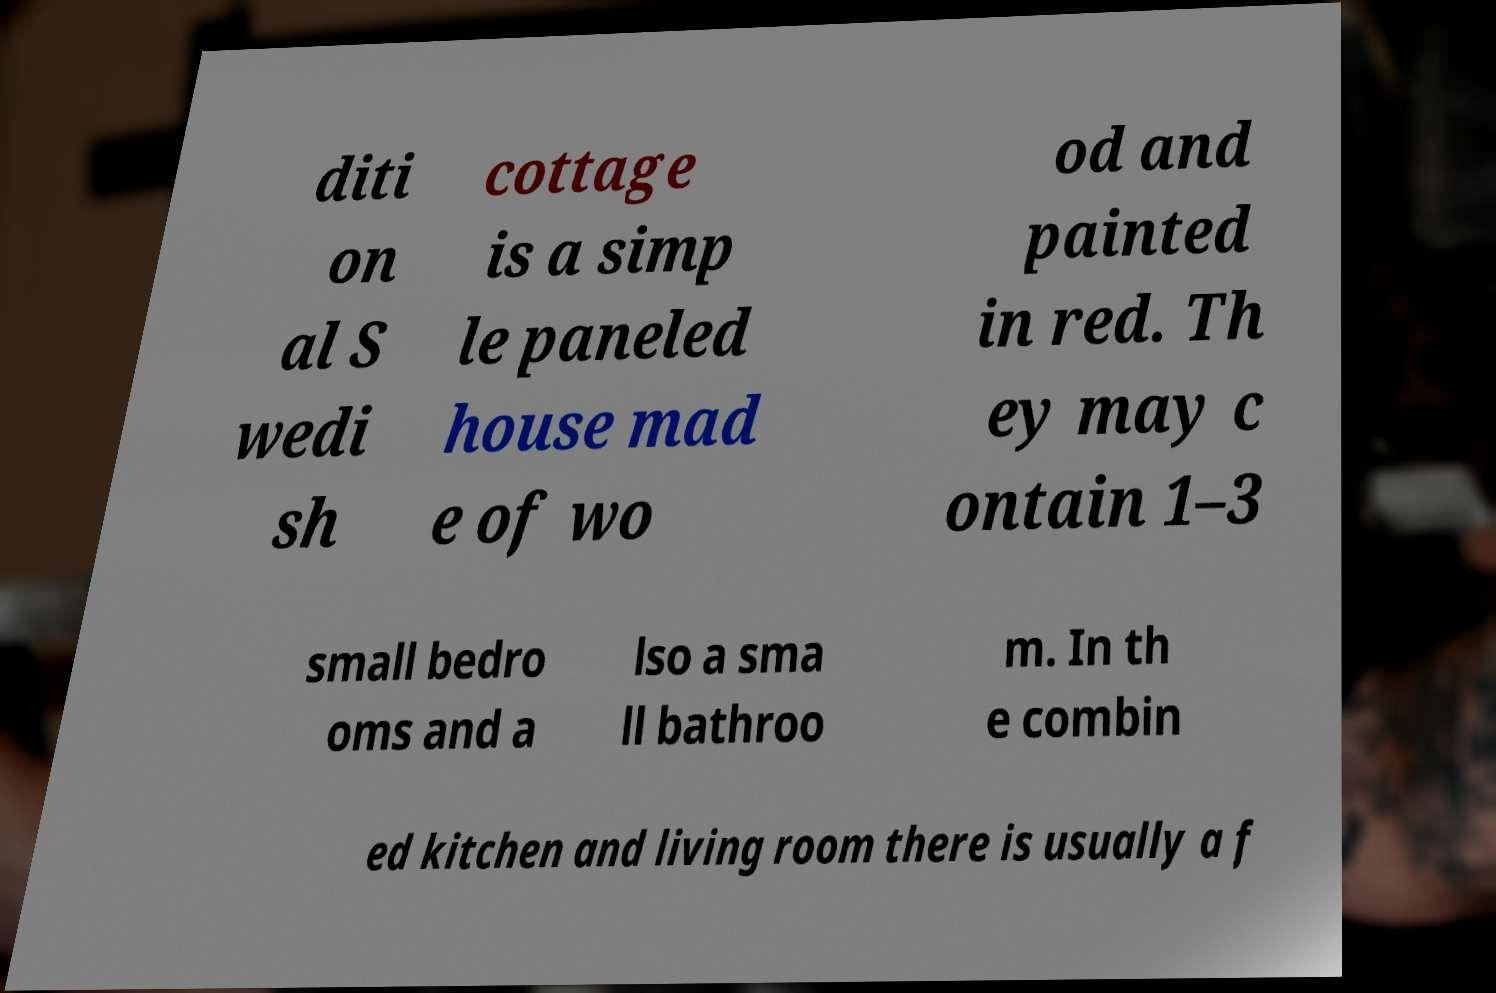I need the written content from this picture converted into text. Can you do that? diti on al S wedi sh cottage is a simp le paneled house mad e of wo od and painted in red. Th ey may c ontain 1–3 small bedro oms and a lso a sma ll bathroo m. In th e combin ed kitchen and living room there is usually a f 